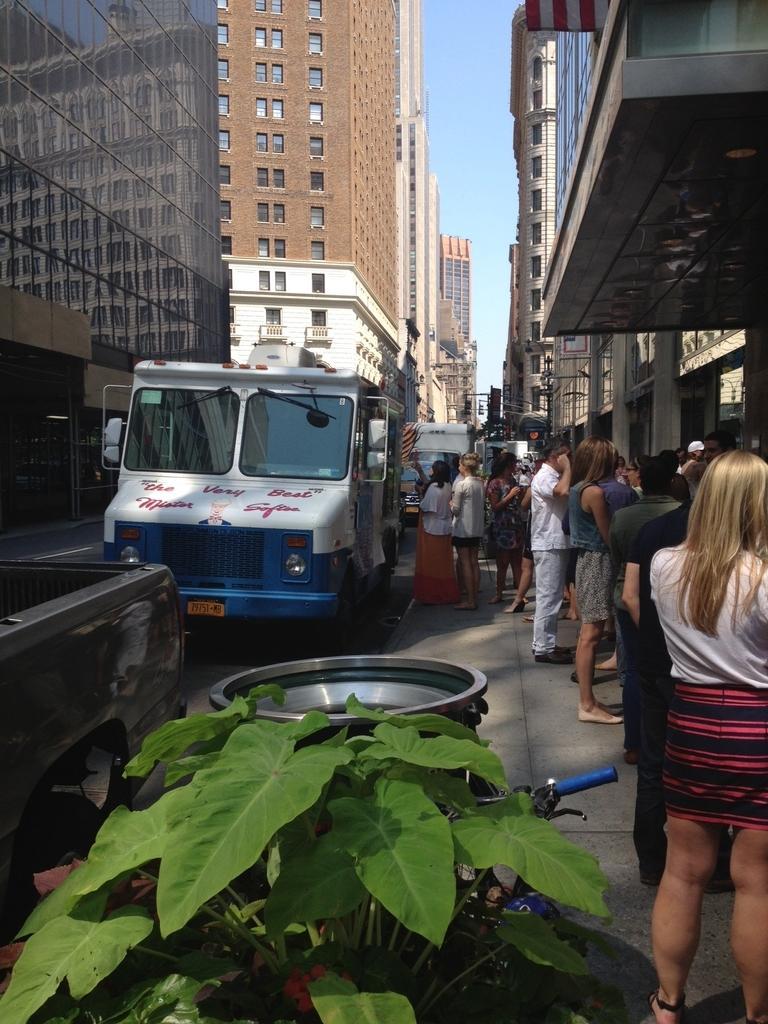In one or two sentences, can you explain what this image depicts? In the center of the image we can see persons, vehicles on the road. On the right side of the image we can see persons, poles, plants and buildings. On the left side of the image we can see buildings. In the background there is a sky. 